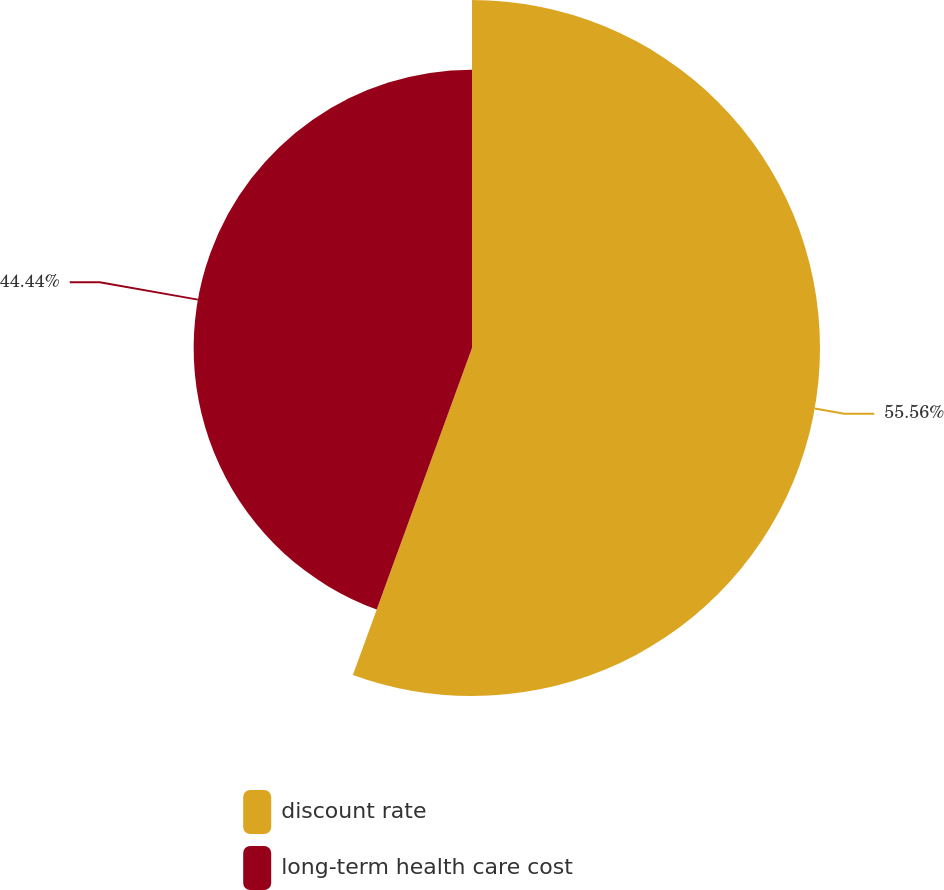Convert chart. <chart><loc_0><loc_0><loc_500><loc_500><pie_chart><fcel>discount rate<fcel>long-term health care cost<nl><fcel>55.56%<fcel>44.44%<nl></chart> 